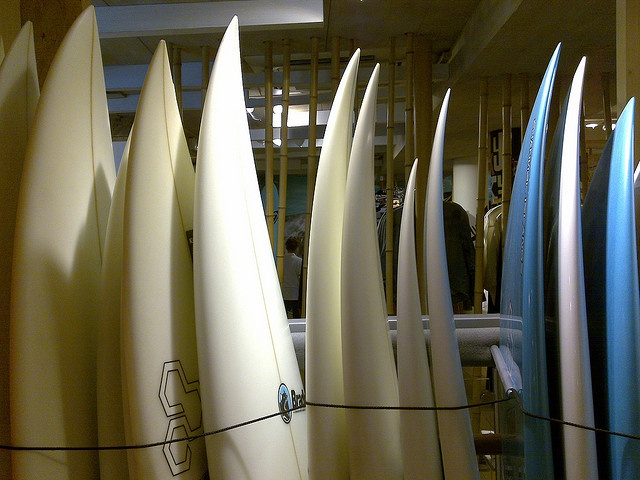Describe the objects in this image and their specific colors. I can see surfboard in black, olive, tan, darkgray, and gray tones, surfboard in black, white, darkgray, lightgray, and gray tones, surfboard in black, olive, darkgray, tan, and beige tones, surfboard in black, blue, and gray tones, and surfboard in black, gray, and olive tones in this image. 